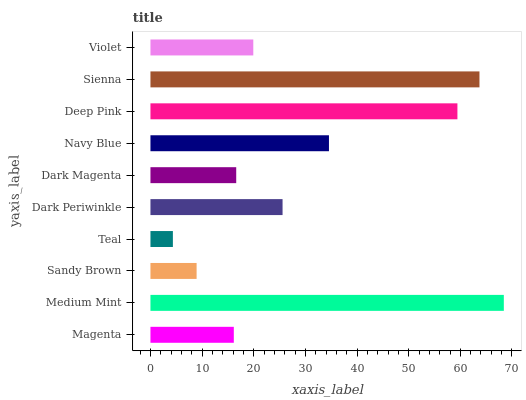Is Teal the minimum?
Answer yes or no. Yes. Is Medium Mint the maximum?
Answer yes or no. Yes. Is Sandy Brown the minimum?
Answer yes or no. No. Is Sandy Brown the maximum?
Answer yes or no. No. Is Medium Mint greater than Sandy Brown?
Answer yes or no. Yes. Is Sandy Brown less than Medium Mint?
Answer yes or no. Yes. Is Sandy Brown greater than Medium Mint?
Answer yes or no. No. Is Medium Mint less than Sandy Brown?
Answer yes or no. No. Is Dark Periwinkle the high median?
Answer yes or no. Yes. Is Violet the low median?
Answer yes or no. Yes. Is Sandy Brown the high median?
Answer yes or no. No. Is Deep Pink the low median?
Answer yes or no. No. 